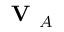<formula> <loc_0><loc_0><loc_500><loc_500>V _ { A }</formula> 